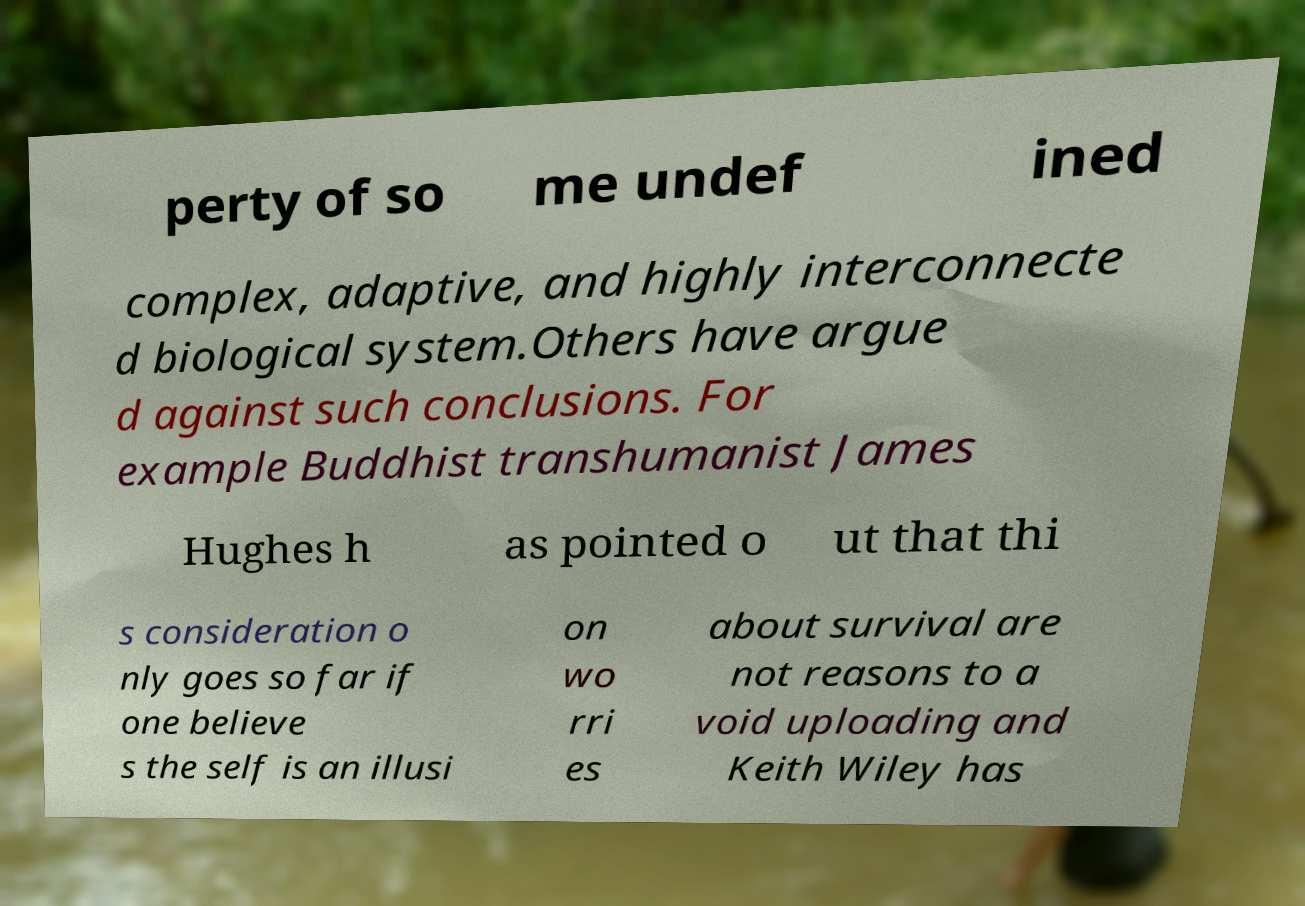Could you extract and type out the text from this image? perty of so me undef ined complex, adaptive, and highly interconnecte d biological system.Others have argue d against such conclusions. For example Buddhist transhumanist James Hughes h as pointed o ut that thi s consideration o nly goes so far if one believe s the self is an illusi on wo rri es about survival are not reasons to a void uploading and Keith Wiley has 